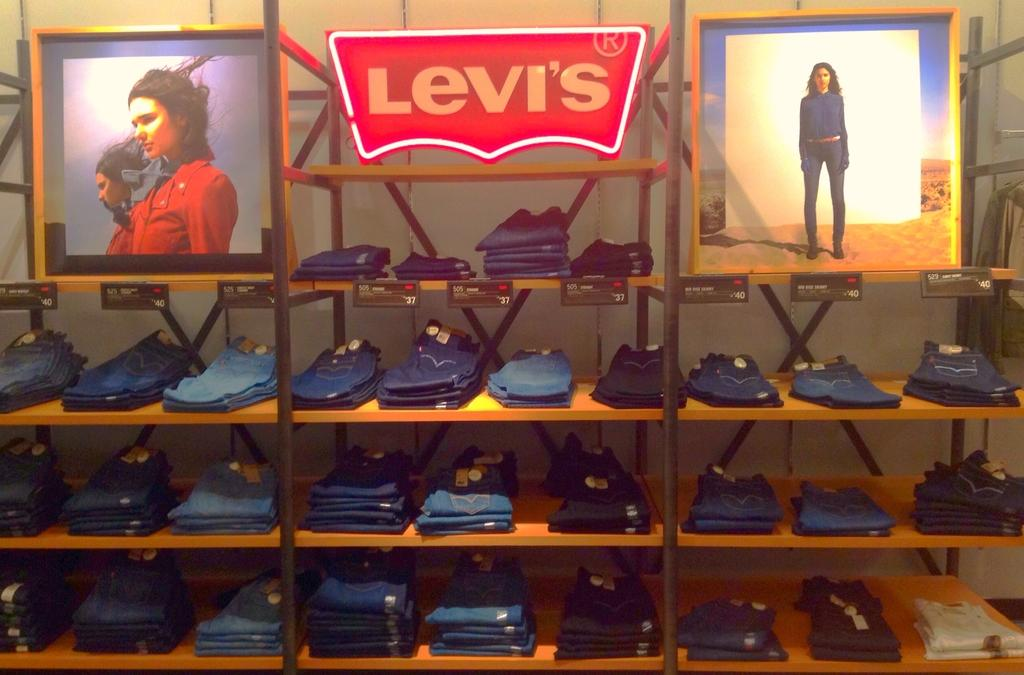What type of clothing items can be seen on the racks in the image? There are racks with pants in the image. What is displayed within the frames in the image? There are frames with images of persons in the image. What is written on the board in the image? There is a board with a name in the image. What type of vertical structures are present in the image? There are poles in the image. What are the small pieces of paper or material attached to the items in the image? There are tags in the image. Where is the lettuce growing in the image? There is no lettuce present in the image. What type of twig can be seen in the image? There is no twig present in the image. 